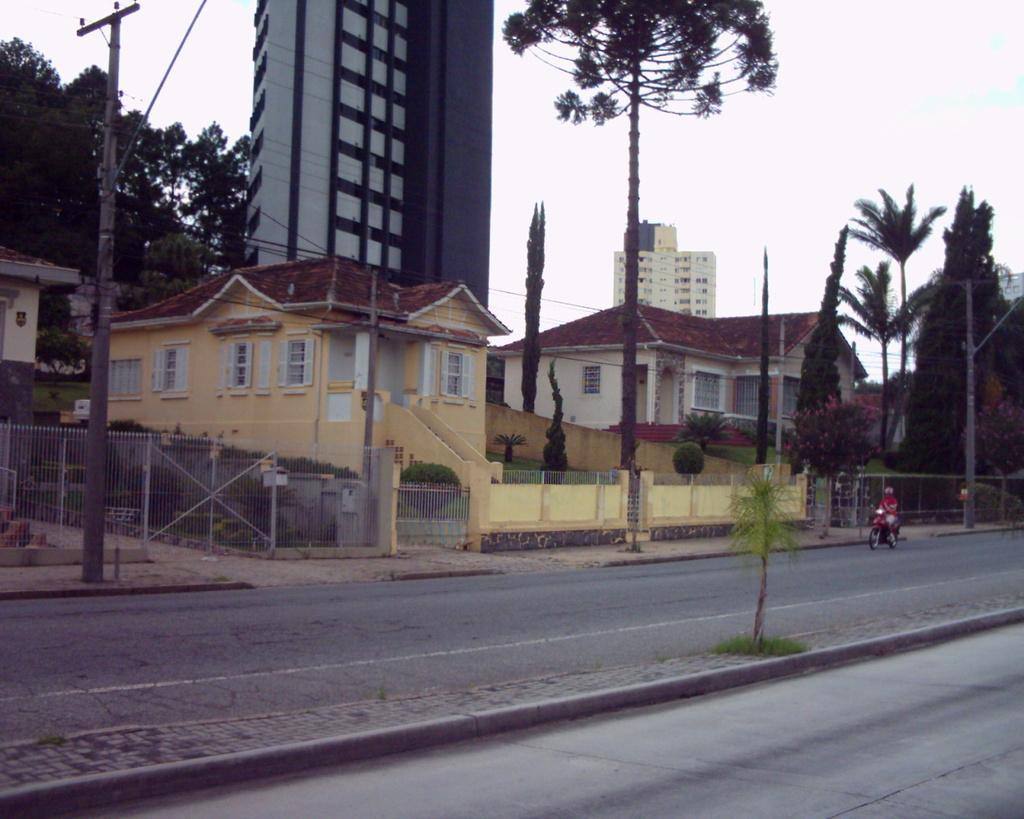Can you describe this image briefly? In this image I can see the person riding the vehicle, background I can see few buildings in cream, gray and white color and I can also see few trees in green color. Background I can see an electric pole and the sky is in white color. 